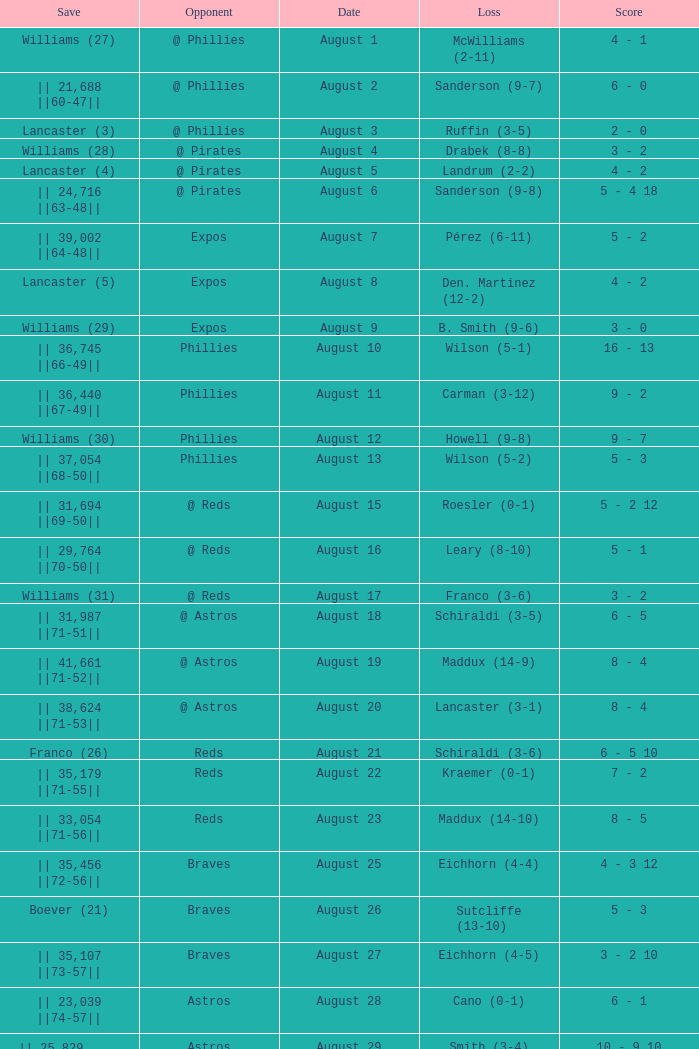Name the date with loss of carman (3-12) August 11. 